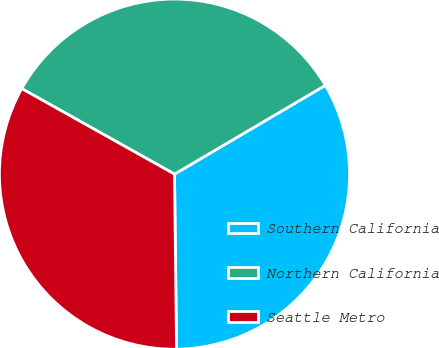<chart> <loc_0><loc_0><loc_500><loc_500><pie_chart><fcel>Southern California<fcel>Northern California<fcel>Seattle Metro<nl><fcel>33.28%<fcel>33.41%<fcel>33.31%<nl></chart> 